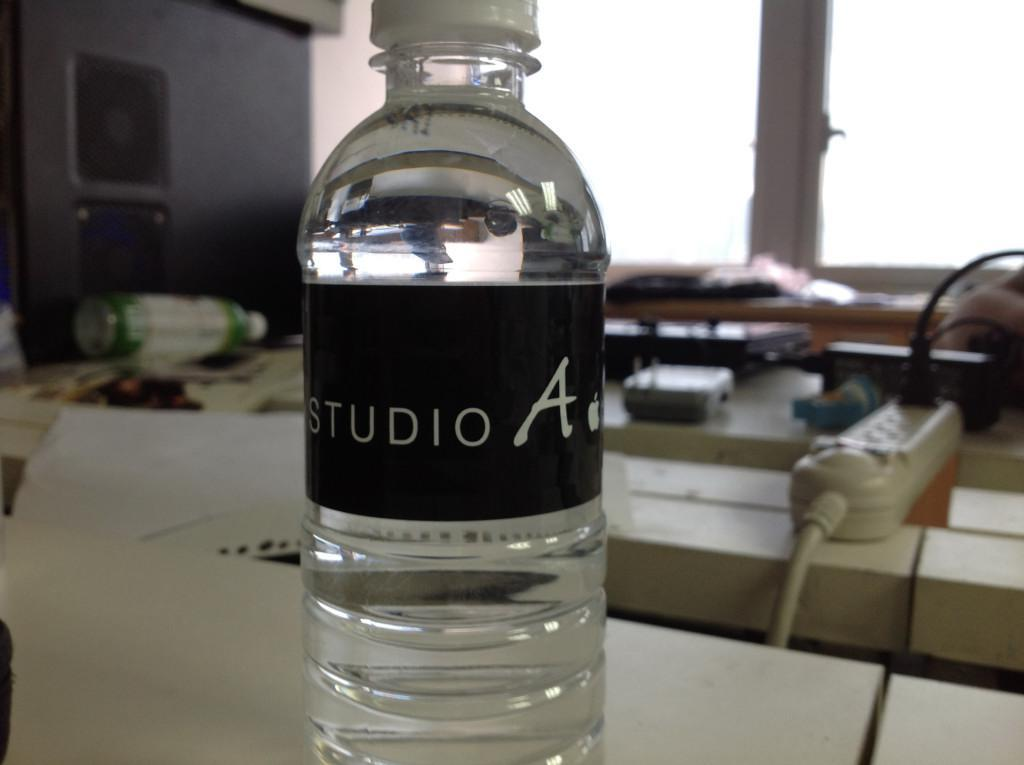<image>
Share a concise interpretation of the image provided. A Studio A bottle of water sitting in a work room. 